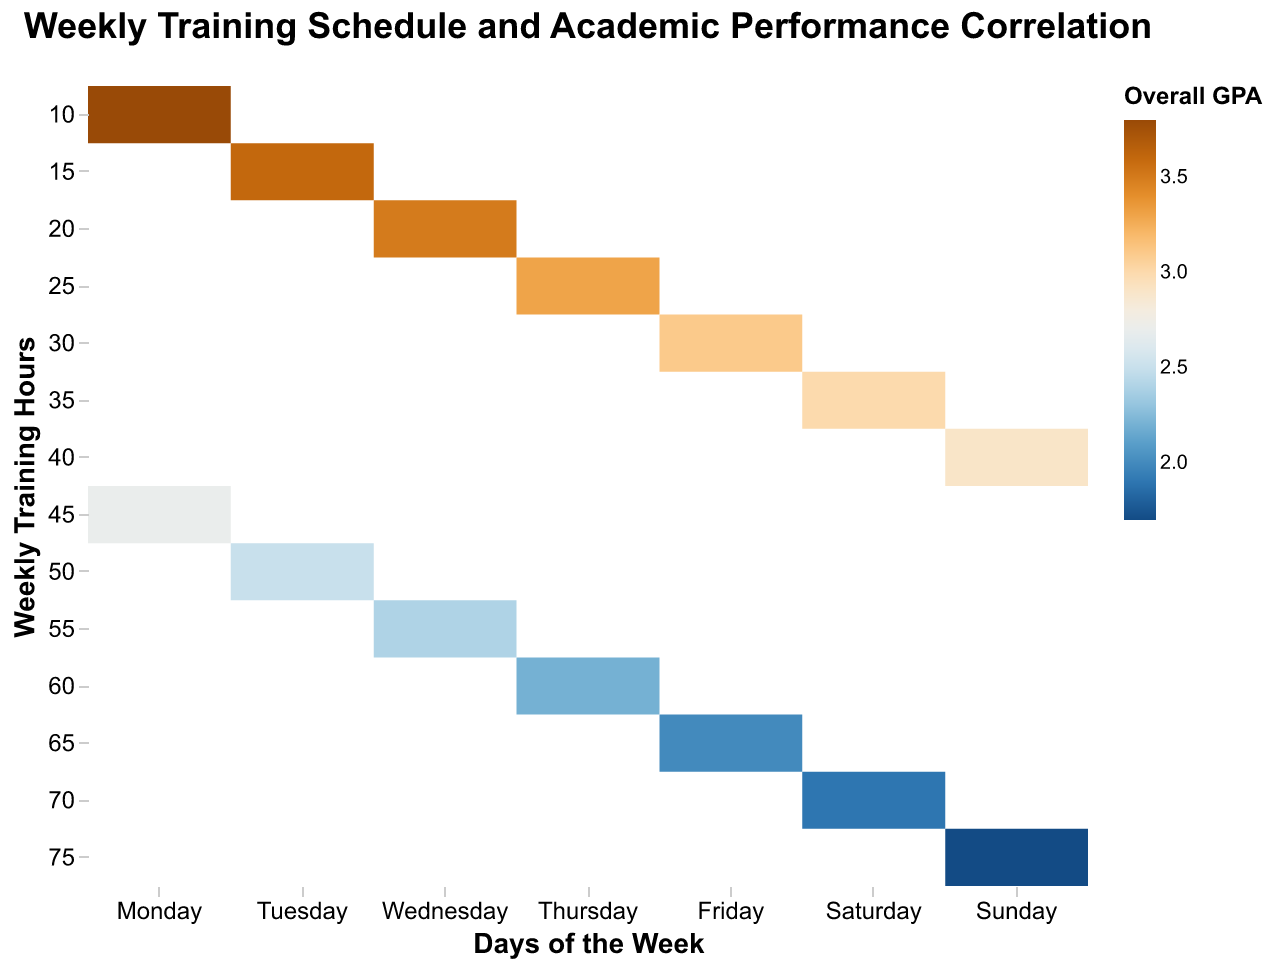What is the title of the heatmap? The title of the heatmap is usually located at the top center of the figure, describing the overall content.
Answer: Weekly Training Schedule and Academic Performance Correlation On which day is the Overall GPA the highest? By looking at the color legend and corresponding days, identify the day with the color closest to the highest GPA. The highest GPA is 3.8, which is on Monday.
Answer: Monday By how much does the GPA decrease when training hours go from 20 to 40 on Wednesday? On Wednesday, the GPA for 20 training hours is 3.5, and for 40 training hours, it's 2.9. The decrease is calculated as 3.5 - 2.9.
Answer: 0.6 Which day shows the highest overall training hours? Identify the day with the color corresponding to the highest training hours. The color range for days of the week shows Sunday with the highest training hours of 75.
Answer: Sunday Which day and training hours combination has the lowest GPA? Identify the cell with the color corresponding to the lowest GPA (1.7) from the color legend and its location on the heatmap. It's seen on Sunday with 75 training hours.
Answer: Sunday, 75 hours What is the average GPA for 30 training hours across all days? Locate all the cells with training hours of 30 and sum up their GPA values. Divide this sum by the number of such cells (3.1 on Friday).
Answer: 3.1 How does the GPA trend as training hours increase from 10 to 70 on Saturday? Observe the color gradient for Saturday. A continuous decrease in GPA is noticed as training hours increase, starting from 3.0 at 35 hours to 1.9 at 70 hours.
Answer: Decreases Which day has the highest number of mandatory practices at 75 training hours? Check where 75 training hours intersect with the highest value for mandatory practices on the respective day. It's Sunday with 7 mandatory practices.
Answer: Sunday What is the sum of mandatory practices for Tuesday when training hours are 15, 50, and 70? Add the number of mandatory practices for these hours on Tuesday: 2 (15 hours) + 5 (50 hours) + 7 (70 hours) to get the total.
Answer: 14 Is there an overall correlation between training hours and GPA? By examining the general color trend across the heatmap, it's observed that as training hours increase, the GPA tends to decrease.
Answer: Negative correlation 